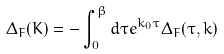Convert formula to latex. <formula><loc_0><loc_0><loc_500><loc_500>\Delta _ { F } ( K ) = - \int _ { 0 } ^ { \beta } d \tau e ^ { k _ { 0 } \tau } \Delta _ { F } ( \tau , k )</formula> 